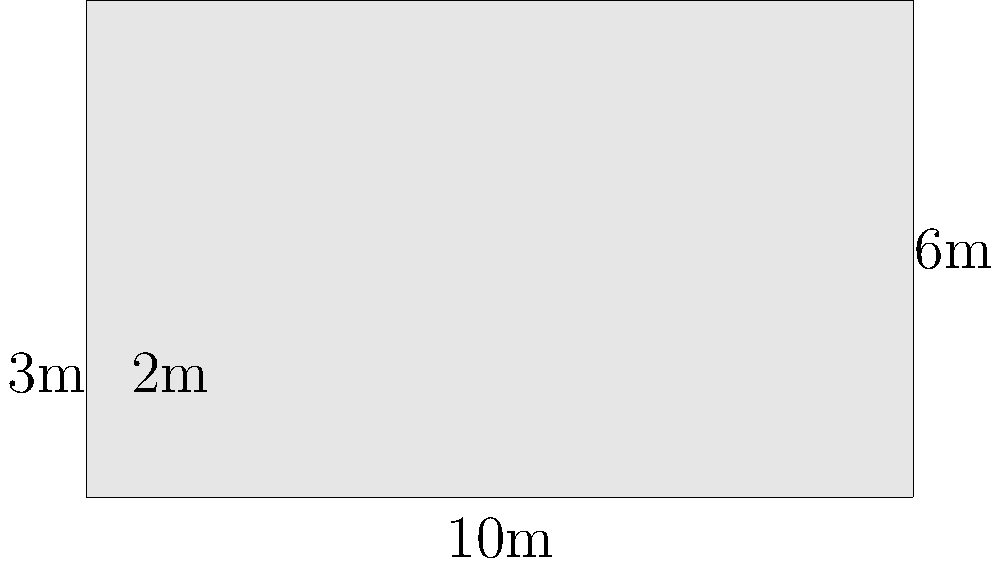A shipping container measures 10m long, 6m wide, and 3m high. Archive boxes measuring 2m x 3m x 2m (length x width x height) need to be packed inside. What is the maximum number of archive boxes that can fit in the container, and what percentage of the container's volume is utilized? To solve this problem, we'll follow these steps:

1. Calculate the volume of the shipping container:
   $V_{container} = 10m \times 6m \times 3m = 180m^3$

2. Calculate the volume of one archive box:
   $V_{box} = 2m \times 3m \times 2m = 12m^3$

3. Determine the number of boxes that can fit along each dimension:
   Length: $10m \div 2m = 5$ boxes
   Width: $6m \div 3m = 2$ boxes
   Height: $3m \div 2m = 1$ box

4. Calculate the total number of boxes that can fit:
   $N_{boxes} = 5 \times 2 \times 1 = 10$ boxes

5. Calculate the total volume occupied by the boxes:
   $V_{occupied} = 10 \times 12m^3 = 120m^3$

6. Calculate the percentage of the container's volume utilized:
   $Utilization = \frac{V_{occupied}}{V_{container}} \times 100\%$
   $= \frac{120m^3}{180m^3} \times 100\% = 66.67\%$

Therefore, the maximum number of archive boxes that can fit in the container is 10, and they utilize 66.67% of the container's volume.
Answer: 10 boxes; 66.67% utilization 